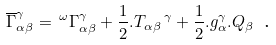<formula> <loc_0><loc_0><loc_500><loc_500>\overline { \Gamma } _ { \alpha \beta } ^ { \gamma } = \, ^ { \omega } \Gamma _ { \alpha \beta } ^ { \gamma } + \frac { 1 } { 2 } . T _ { \alpha \beta } \, ^ { \gamma } + \frac { 1 } { 2 } . g _ { \alpha } ^ { \gamma } . Q _ { \beta } \text { .}</formula> 